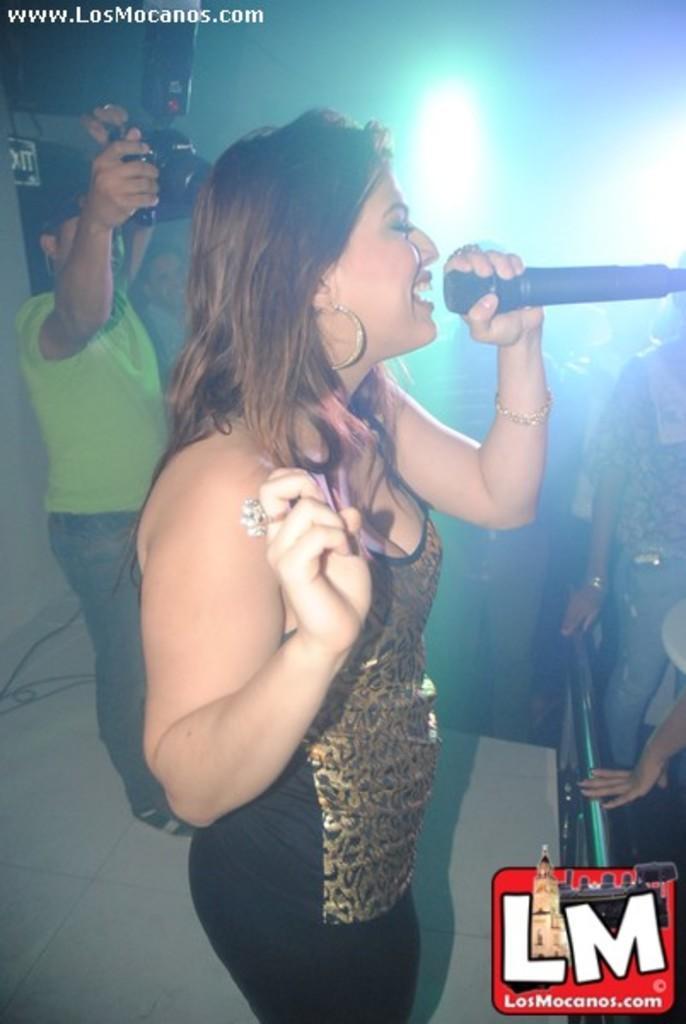Can you describe this image briefly? In this image there are group of persons who are standing at the middle of the image there is a girl who is holding microphone in her hand and at the left side of the image there is a person taking a photograph. 